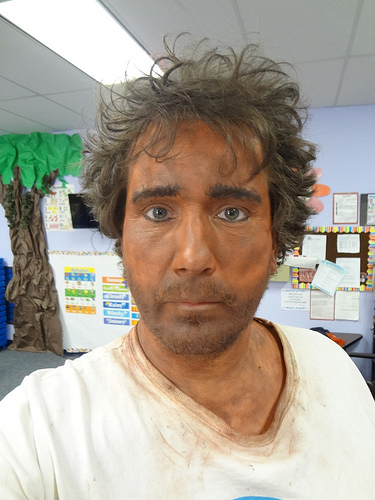<image>
Can you confirm if the man is behind the paper tree? No. The man is not behind the paper tree. From this viewpoint, the man appears to be positioned elsewhere in the scene. 